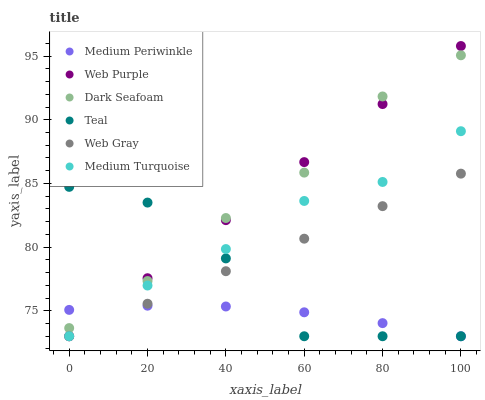Does Medium Periwinkle have the minimum area under the curve?
Answer yes or no. Yes. Does Web Purple have the maximum area under the curve?
Answer yes or no. Yes. Does Medium Turquoise have the minimum area under the curve?
Answer yes or no. No. Does Medium Turquoise have the maximum area under the curve?
Answer yes or no. No. Is Web Gray the smoothest?
Answer yes or no. Yes. Is Teal the roughest?
Answer yes or no. Yes. Is Medium Turquoise the smoothest?
Answer yes or no. No. Is Medium Turquoise the roughest?
Answer yes or no. No. Does Web Gray have the lowest value?
Answer yes or no. Yes. Does Dark Seafoam have the lowest value?
Answer yes or no. No. Does Web Purple have the highest value?
Answer yes or no. Yes. Does Medium Turquoise have the highest value?
Answer yes or no. No. Is Medium Turquoise less than Dark Seafoam?
Answer yes or no. Yes. Is Dark Seafoam greater than Web Gray?
Answer yes or no. Yes. Does Dark Seafoam intersect Web Purple?
Answer yes or no. Yes. Is Dark Seafoam less than Web Purple?
Answer yes or no. No. Is Dark Seafoam greater than Web Purple?
Answer yes or no. No. Does Medium Turquoise intersect Dark Seafoam?
Answer yes or no. No. 